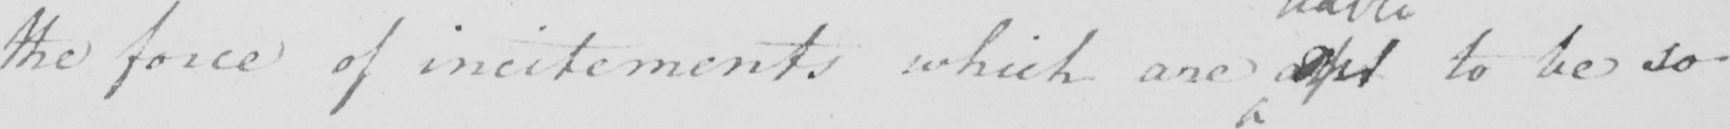What does this handwritten line say? the force of incitements which are apt to be so 